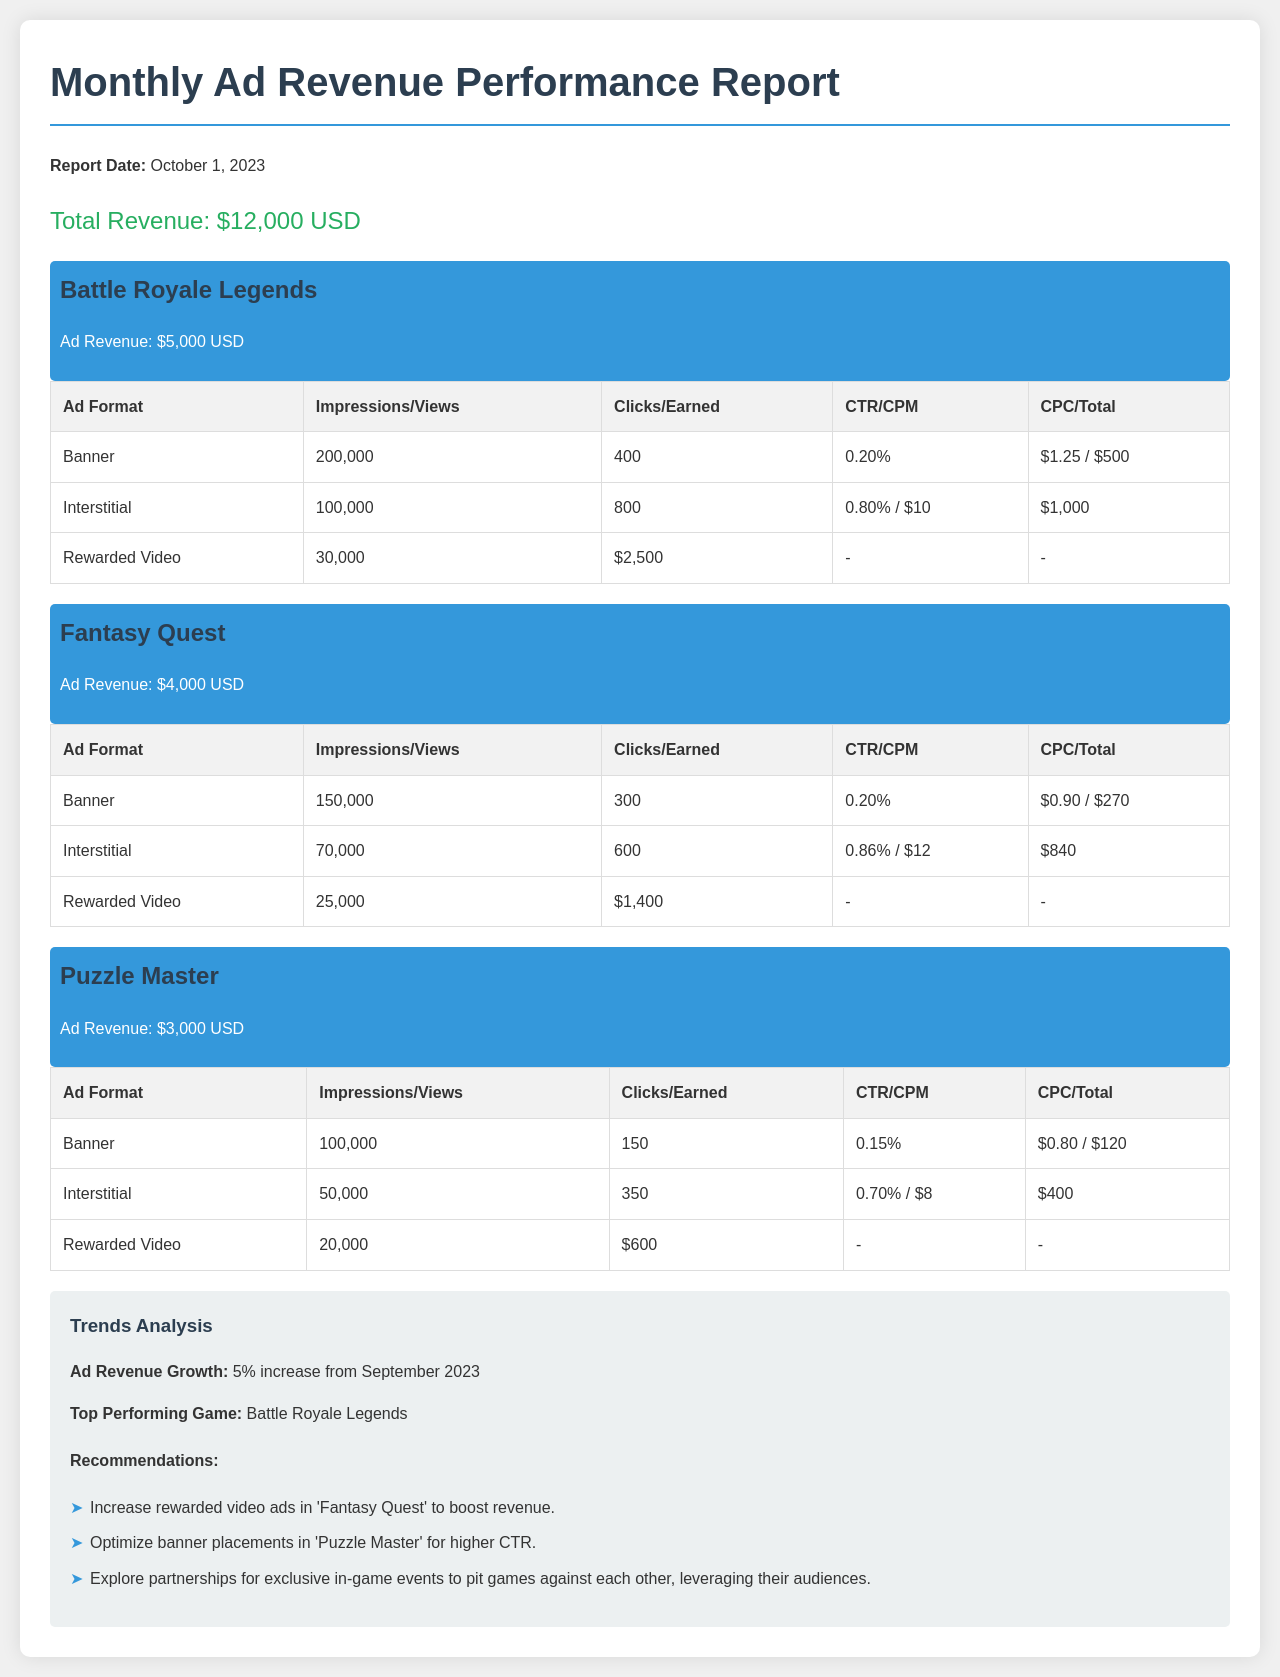What is the total revenue? The total revenue is the sum of revenue from all games listed in the document, which amounts to $5,000 + $4,000 + $3,000 = $12,000 USD.
Answer: $12,000 USD Which game generated the highest ad revenue? The document identifies the top-performing game based on ad revenue, which is Battle Royale Legends.
Answer: Battle Royale Legends What was the ad revenue for Fantasy Quest? The document explicitly states the ad revenue generated by Fantasy Quest.
Answer: $4,000 USD How many impressions did the interstitial ads for Puzzle Master receive? The table provides the number of impressions for interstitial ads specifically for the game Puzzle Master, which is 50,000.
Answer: 50,000 What percentage increase in ad revenue is noted from September 2023? The trends analysis section mentions the percentage increase in ad revenue from the previous month, which is 5%.
Answer: 5% What recommendation is given for increasing revenue in Fantasy Quest? The recommendations section suggests a specific action to boost revenue in Fantasy Quest, which is to increase rewarded video ads.
Answer: Increase rewarded video ads What was the Click-Through Rate (CTR) for the banner ads in Puzzle Master? The document outlines the CTR for banner ads specifically in the section for Puzzle Master, which is 0.15%.
Answer: 0.15% How many clicks were earned from interstitial ads in Battle Royale Legends? The table provides the number of clicks earned from interstitial ads in the game, which is 800.
Answer: 800 